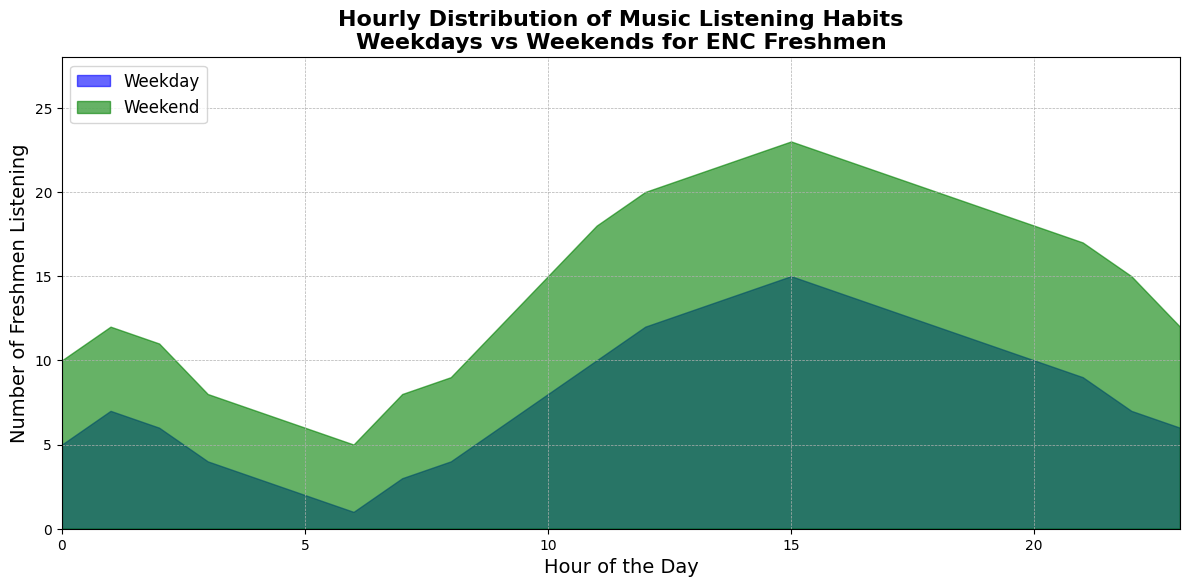Which hour has the highest number of freshmen listening to music on weekends? To find the hour with the highest number of freshmen listening on weekends, look at the green area chart segments and find the peak. The peak value for weekends is at hour 15 with 23 freshmen listening.
Answer: Hour 15 During which hour is the difference between weekday and weekend music listening habits the greatest? The difference can be calculated by subtracting the weekday value from the weekend value for each hour. The greatest difference is at hour 15 where the difference is (23 - 15) = 8.
Answer: Hour 15 How does the number of freshmen listening at 9 a.m. on weekends compare to weekdays? Check the values at hour 9 for both weekdays and weekends. For weekends, the number is 12, and for weekdays, it is 6. Compare these values: 12 > 6.
Answer: More on weekends What is the total number of freshmen listening to music from 10 a.m. to 1 p.m. on weekdays? Sum the values from hour 10 to 13 for weekdays: 8 (10 a.m.) + 10 (11 a.m.) + 12 (12 p.m.) + 13 (1 p.m.) = 43.
Answer: 43 Compare the number of listeners at 4 a.m. on weekdays to the number at 4 a.m. on weekends. Look at the values for hour 4 on both weekdays and weekends. The number for weekdays is 3 and for weekends is 7. Compare these values: 7 > 3.
Answer: More on weekends What is the average number of listeners at noon across weekdays and weekends? Find the values for noon on both weekdays and weekends: 12 (weekdays) and 20 (weekends). The average is (12 + 20) / 2 = 16.
Answer: 16 Which hour has the least number of freshmen listening to music on weekdays? The lowest value on the blue area chart represents the least number of listeners on weekdays. This value is found at hour 6 with only 1 freshman listening.
Answer: Hour 6 Is there any hour where the number of weekday listeners equals the number of weekend listeners? Examine both area charts to see if any of the segments match in height at the same hour. No hours have equal listeners between weekdays and weekends.
Answer: No What trend can be observed in music listening habits from noon to 6 p.m. on weekends? Observing the green area chart from hour 12 to 18, the number of listeners starts high at 20 and sustains around the 20-23 range before slightly dropping to 19 by hour 6.
Answer: Sustained high How does the music listening trend change from 5 a.m. to 8 a.m. on weekdays? Observing the blue area chart from hour 5 to 8, the number of listeners increases gradually from 2 to 3 and then to 4.
Answer: Gradually increases 